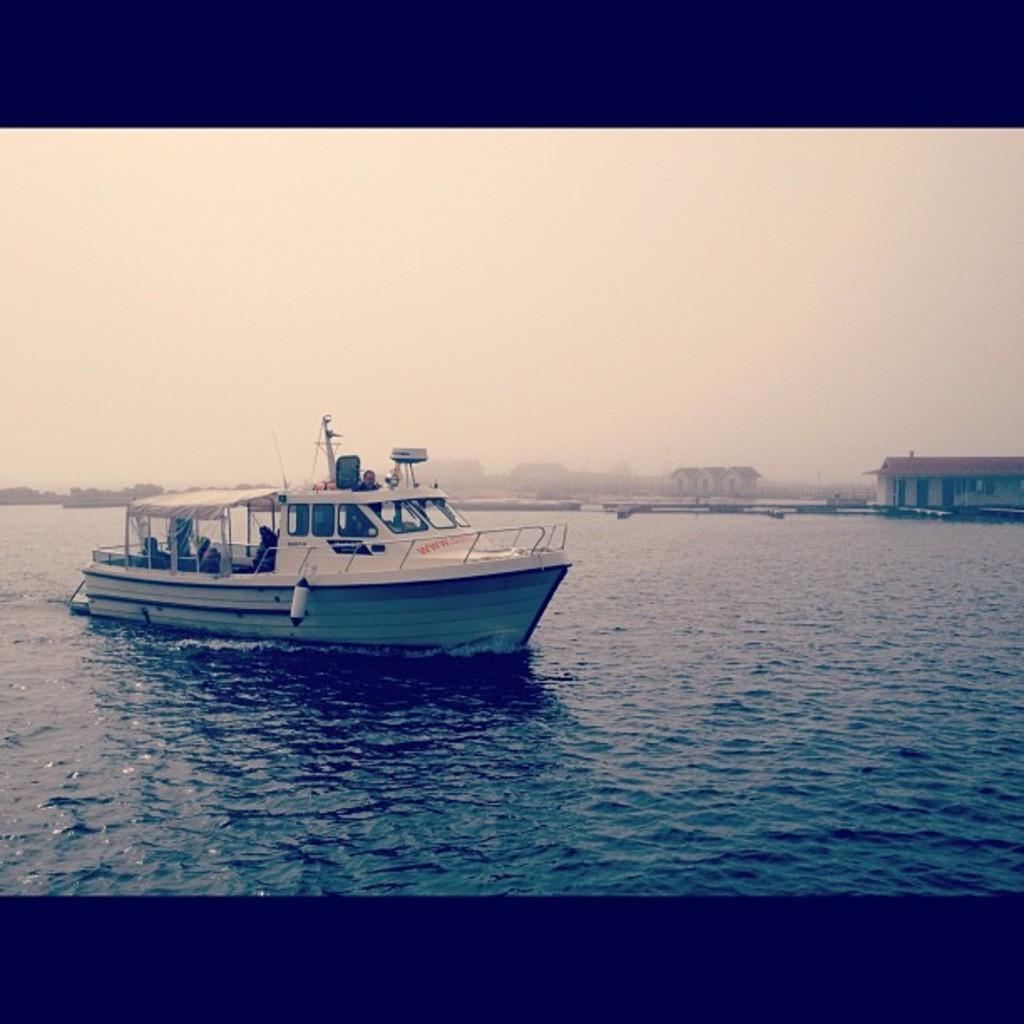What is the main subject of the image? The main subject of the image is a boat in the water. What features does the boat have? The boat has windows and a railing. What can be seen in the background of the image? There are buildings and the sky visible in the background of the image. How many friends are shown regretting their decision to attack the boat in the image? There is no indication of friends, regret, or an attack in the image; it simply shows a boat in the water with windows and a railing, along with buildings and the sky in the background. 